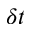Convert formula to latex. <formula><loc_0><loc_0><loc_500><loc_500>\delta t</formula> 